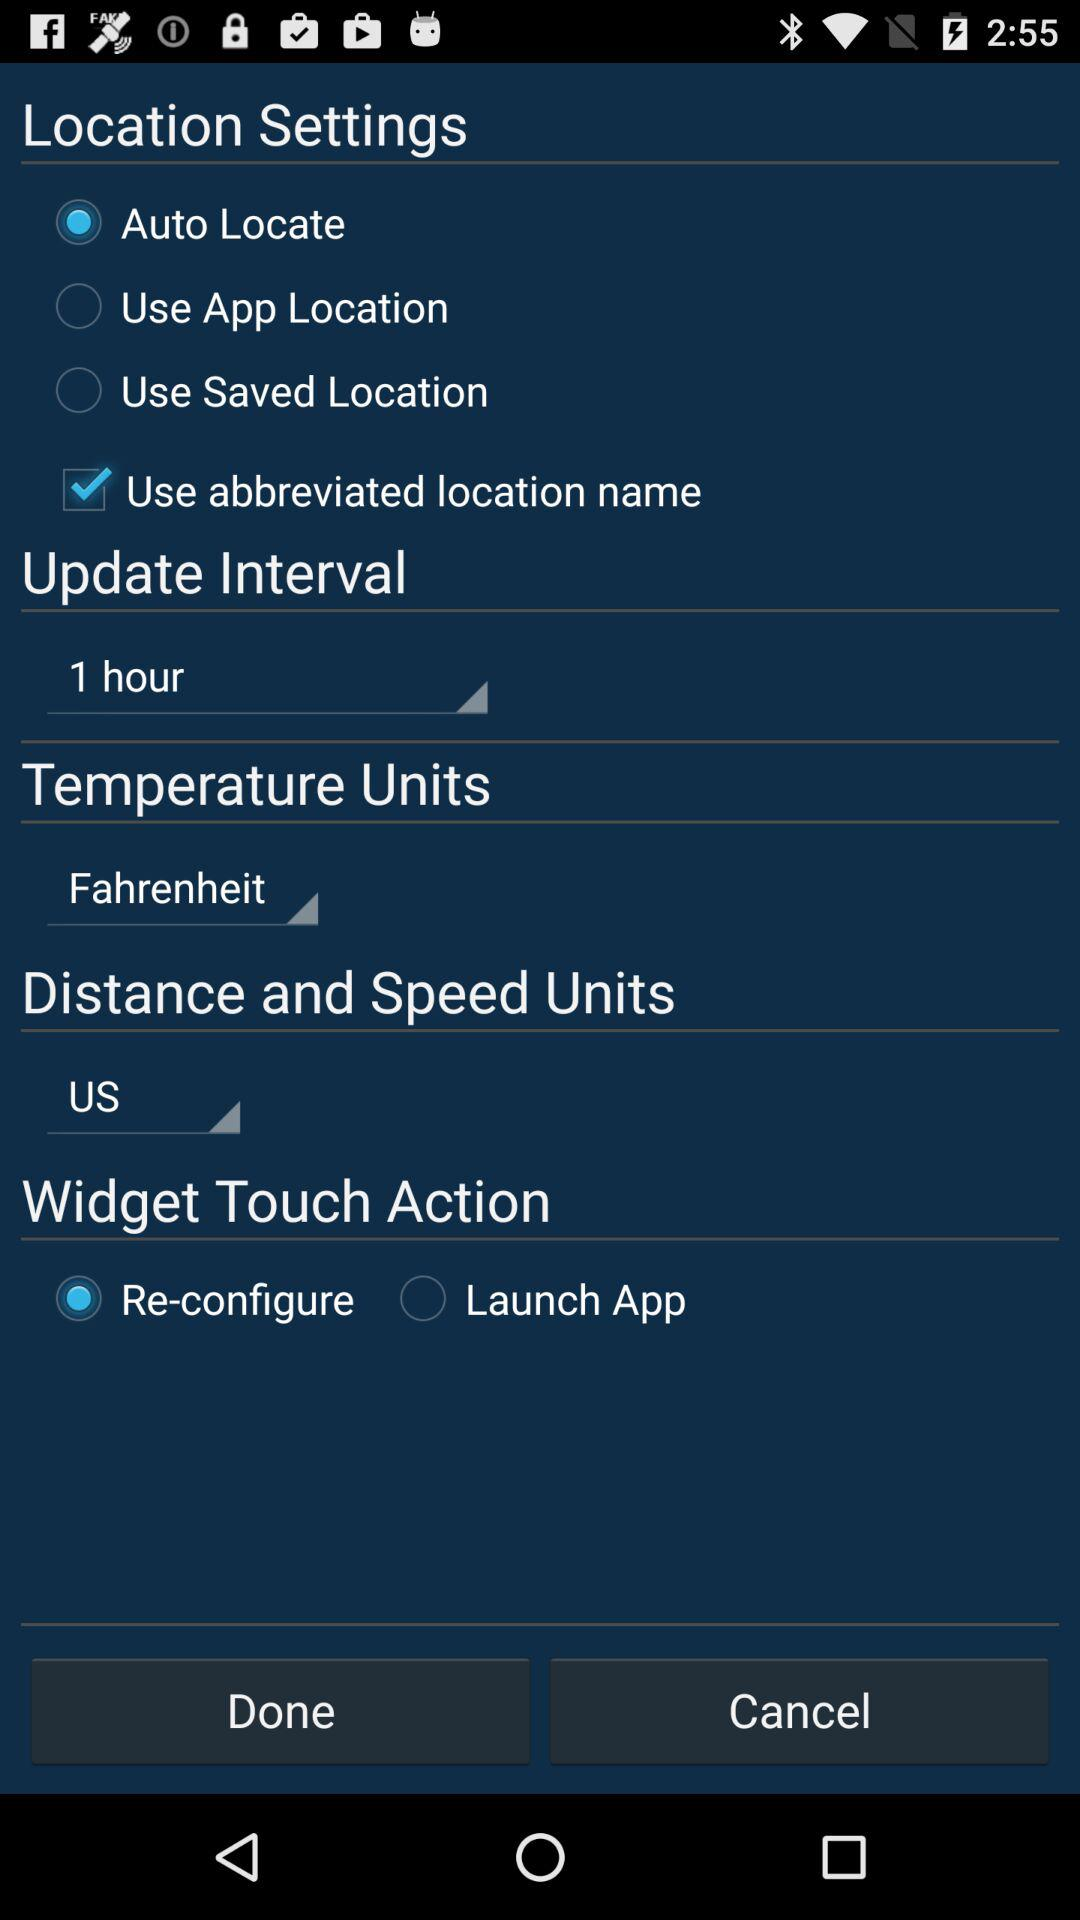Which option is selected in "Widget Touch Action"? The selected option is "Re-configure". 